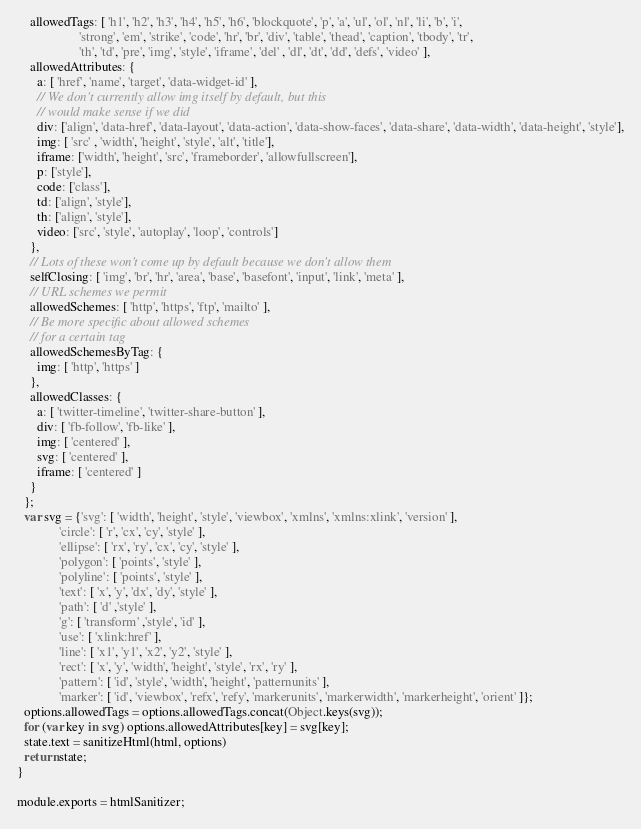<code> <loc_0><loc_0><loc_500><loc_500><_JavaScript_>    allowedTags: [ 'h1', 'h2', 'h3', 'h4', 'h5', 'h6', 'blockquote', 'p', 'a', 'ul', 'ol', 'nl', 'li', 'b', 'i', 
                   'strong', 'em', 'strike', 'code', 'hr', 'br', 'div', 'table', 'thead', 'caption', 'tbody', 'tr', 
                   'th', 'td', 'pre', 'img', 'style', 'iframe', 'del' , 'dl', 'dt', 'dd', 'defs', 'video' ],
    allowedAttributes: {
      a: [ 'href', 'name', 'target', 'data-widget-id' ],
      // We don't currently allow img itself by default, but this
      // would make sense if we did
      div: ['align', 'data-href', 'data-layout', 'data-action', 'data-show-faces', 'data-share', 'data-width', 'data-height', 'style'],
      img: [ 'src' , 'width', 'height', 'style', 'alt', 'title'],
      iframe: ['width', 'height', 'src', 'frameborder', 'allowfullscreen'],
      p: ['style'],
      code: ['class'],
      td: ['align', 'style'],
      th: ['align', 'style'],
      video: ['src', 'style', 'autoplay', 'loop', 'controls']
    },
    // Lots of these won't come up by default because we don't allow them
    selfClosing: [ 'img', 'br', 'hr', 'area', 'base', 'basefont', 'input', 'link', 'meta' ],
    // URL schemes we permit
    allowedSchemes: [ 'http', 'https', 'ftp', 'mailto' ],
    // Be more specific about allowed schemes
    // for a certain tag
    allowedSchemesByTag: {
      img: [ 'http', 'https' ]
    },
    allowedClasses: {
      a: [ 'twitter-timeline', 'twitter-share-button' ],
      div: [ 'fb-follow', 'fb-like' ],
      img: [ 'centered' ],
      svg: [ 'centered' ],
      iframe: [ 'centered' ]
    }        
  };
  var svg = {'svg': [ 'width', 'height', 'style', 'viewbox', 'xmlns', 'xmlns:xlink', 'version' ], 
             'circle': [ 'r', 'cx', 'cy', 'style' ], 
             'ellipse': [ 'rx', 'ry', 'cx', 'cy', 'style' ], 
             'polygon': [ 'points', 'style' ], 
             'polyline': [ 'points', 'style' ],
             'text': [ 'x', 'y', 'dx', 'dy', 'style' ], 
             'path': [ 'd' ,'style' ],
             'g': [ 'transform' ,'style', 'id' ],
             'use': [ 'xlink:href' ],      
             'line': [ 'x1', 'y1', 'x2', 'y2', 'style' ], 
             'rect': [ 'x', 'y', 'width', 'height', 'style', 'rx', 'ry' ],
             'pattern': [ 'id', 'style', 'width', 'height', 'patternunits' ],
             'marker': [ 'id', 'viewbox', 'refx', 'refy', 'markerunits', 'markerwidth', 'markerheight', 'orient' ]};
  options.allowedTags = options.allowedTags.concat(Object.keys(svg));
  for (var key in svg) options.allowedAttributes[key] = svg[key];
  state.text = sanitizeHtml(html, options)
  return state;
}

module.exports = htmlSanitizer;
</code> 